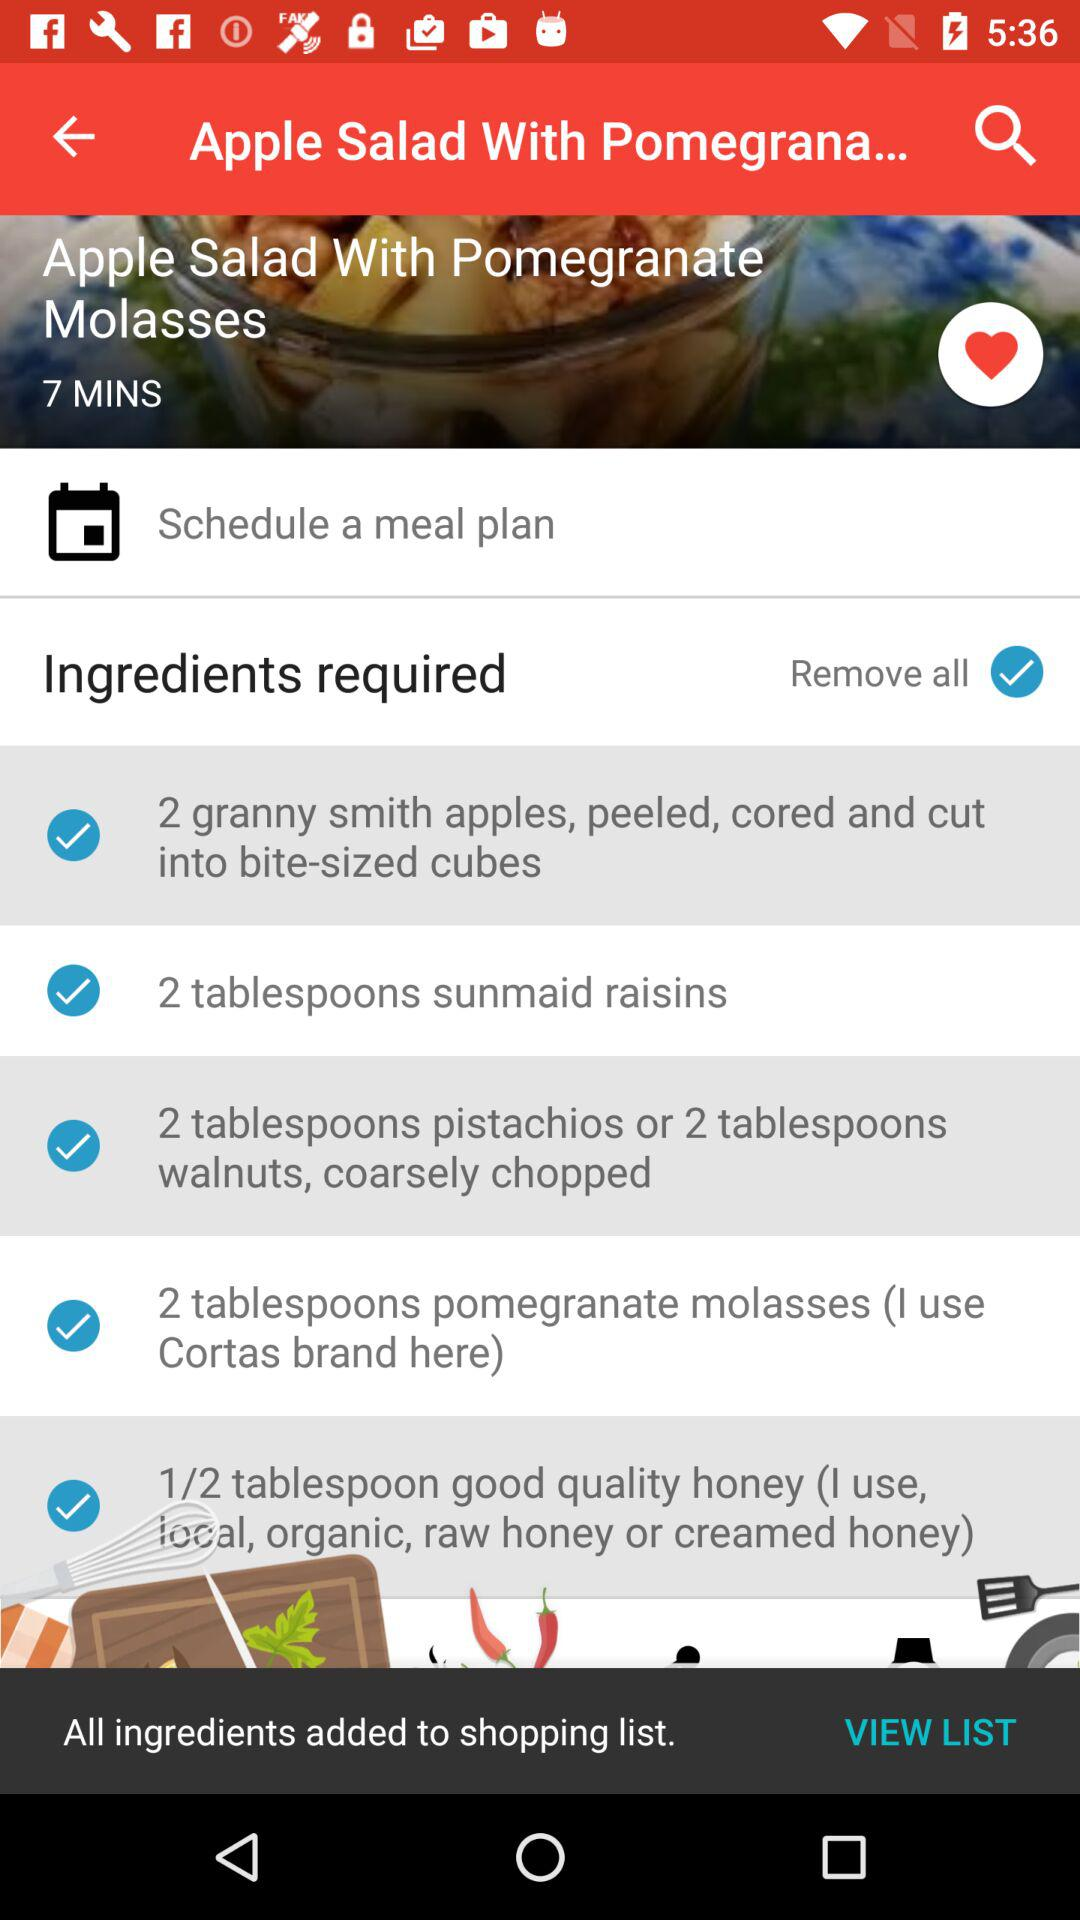How many of the ingredients are nuts?
Answer the question using a single word or phrase. 2 